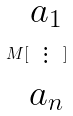<formula> <loc_0><loc_0><loc_500><loc_500>M [ \begin{matrix} a _ { 1 } \\ \vdots \\ a _ { n } \end{matrix} ]</formula> 